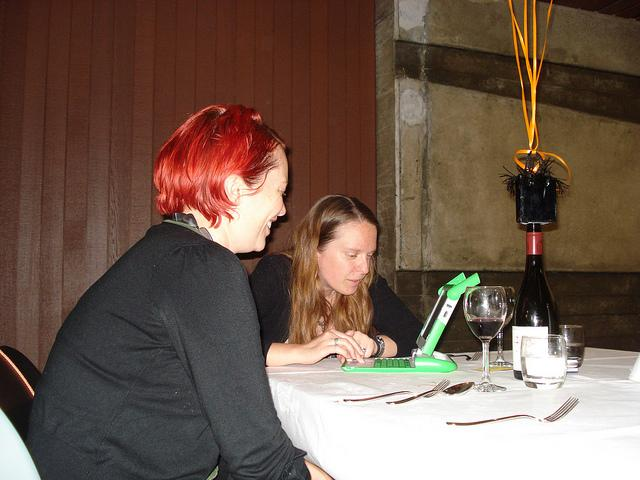Which process has been performed on the closer lady's hair? dye 